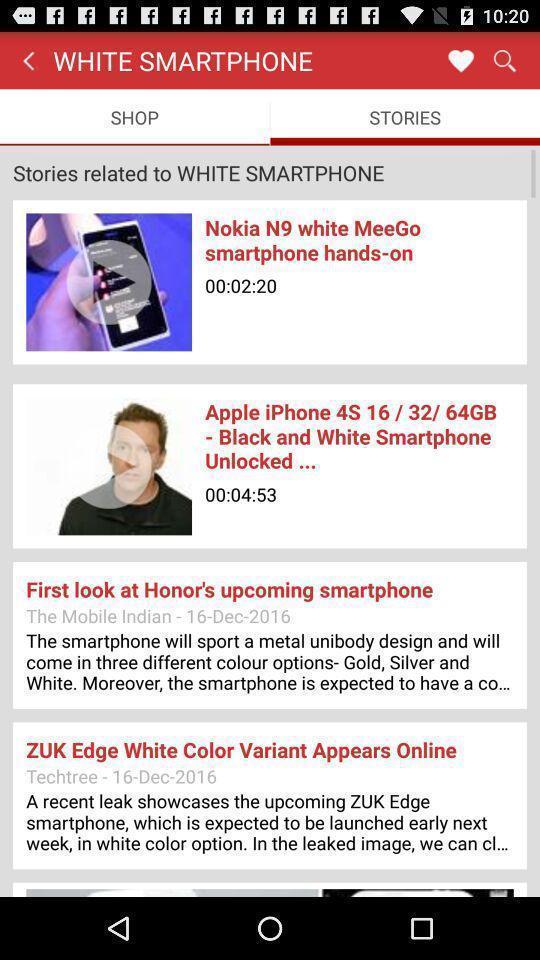Give me a narrative description of this picture. Screen shows top stories of streaming news. 